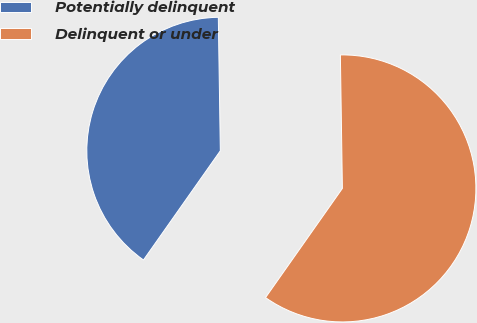Convert chart to OTSL. <chart><loc_0><loc_0><loc_500><loc_500><pie_chart><fcel>Potentially delinquent<fcel>Delinquent or under<nl><fcel>40.0%<fcel>60.0%<nl></chart> 